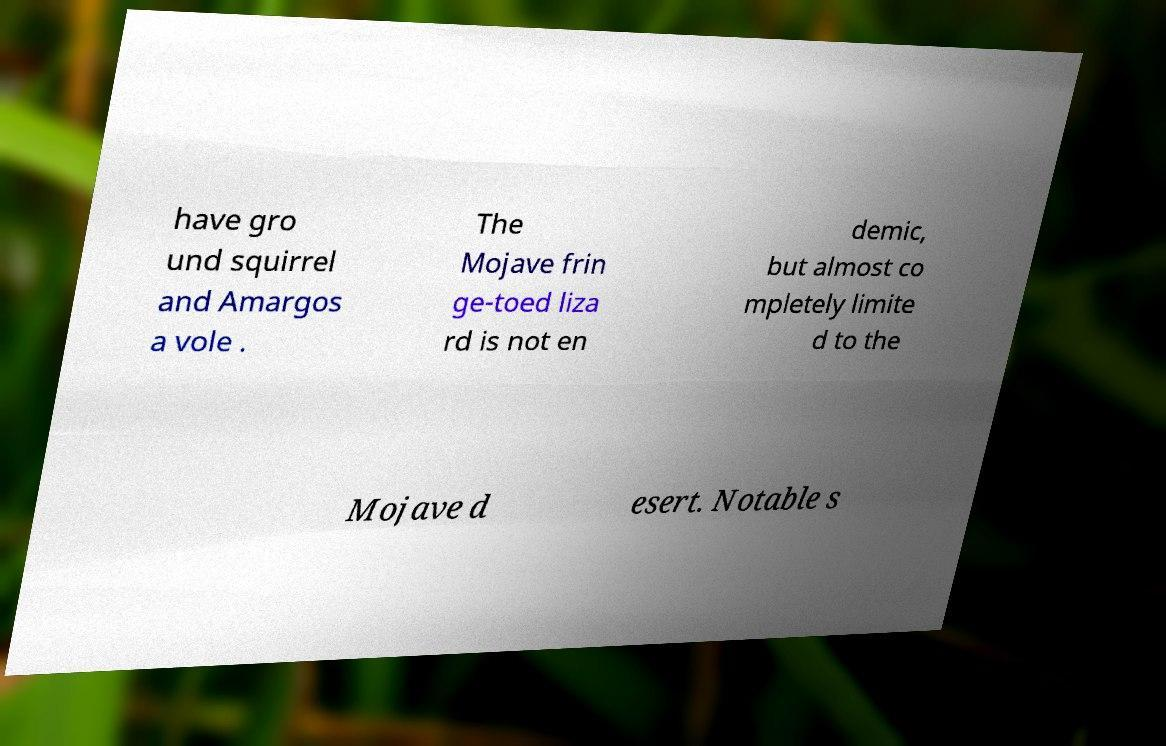I need the written content from this picture converted into text. Can you do that? have gro und squirrel and Amargos a vole . The Mojave frin ge-toed liza rd is not en demic, but almost co mpletely limite d to the Mojave d esert. Notable s 